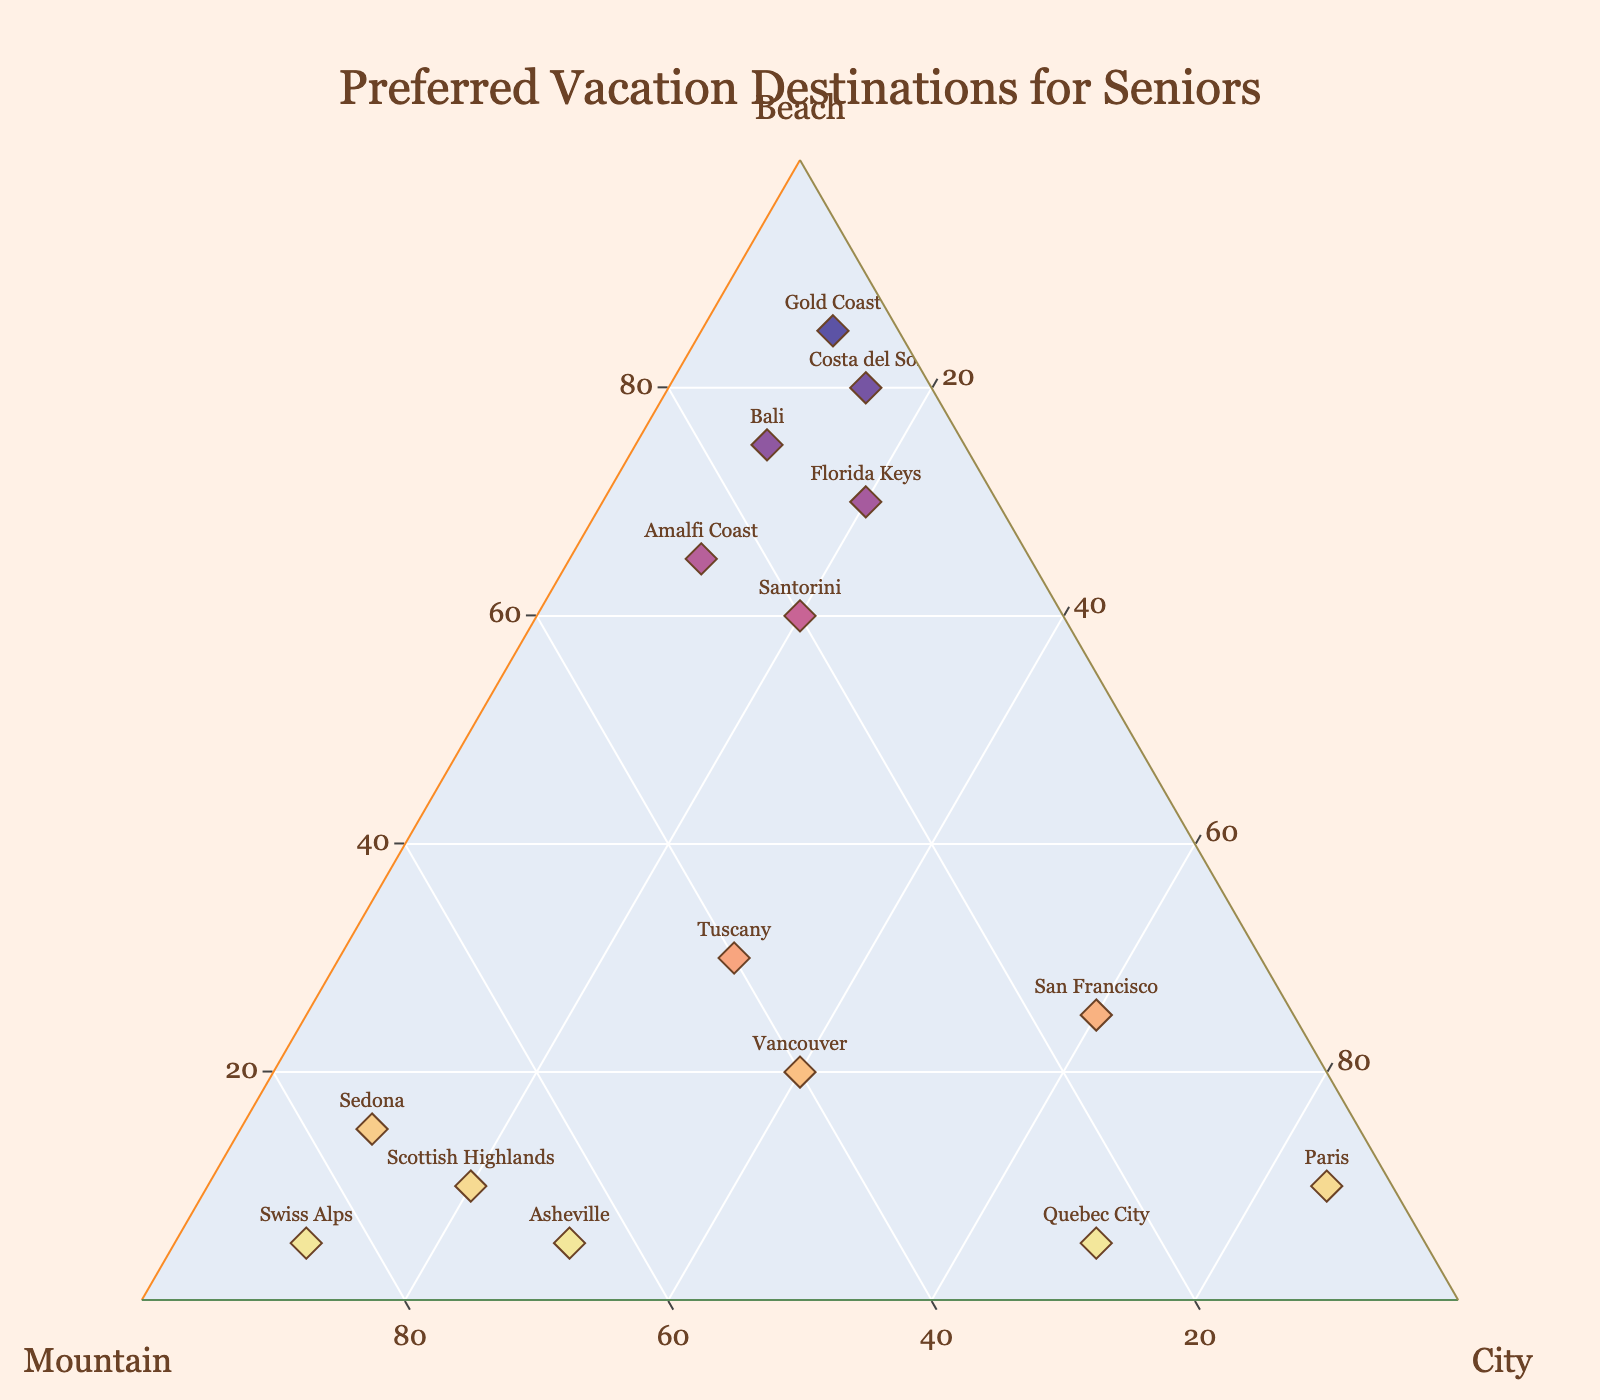what's the title of the figure? The title is at the top center of the plot and is clearly visible in a larger font.
Answer: "Preferred Vacation Destinations for Seniors" how many destinations are represented in the plot? Each marker on the ternary plot represents a different destination. Counting these markers will give the total number of destinations.
Answer: 15 which destination prefers beach vacations the most? Look for the marker that is the closest to the "Beach" axis or check the marker with the highest value in the "Beach" component.
Answer: Gold Coast which destination has the highest preference for city breaks? Find the marker that is nearest to the "City" axis or has the highest "City" value indicated on the plot.
Answer: Paris which destinations have equal preference for mountain and city breaks? Locate markers where the "Mountain" and "City" values are the same.
Answer: Tuscany, Vancouver what is the range of beach preference percentages across all destinations? Identify the minimum and maximum values in the "Beach" component from the markers on the plot.
Answer: 5% to 85% which destinations have a mountain preference greater than 50%? Look for markers that are above the 50% line on the "Mountain" axis.
Answer: Sedona, Swiss Alps, Scottish Highlands, Asheville compare the vacation preferences of Bali and Santorini. Which one prefers the beach more? Locate the markers for Bali and Santorini and compare their positions along the "Beach" axis.
Answer: Bali which destination is the most balanced between beach, mountain, and city preferences? Find the marker closest to the center of the ternary plot, indicating roughly equal preferences for all three components.
Answer: Tuscany estimate the average beach preference percentage for the given destinations. Sum up the "Beach" percentages for all destinations and divide by the total number of destinations.
Answer: (70 + 30 + 15 + 5 + 80 + 5 + 10 + 65 + 20 + 10 + 75 + 25 + 60 + 5 + 85)/15 = 37.67% 